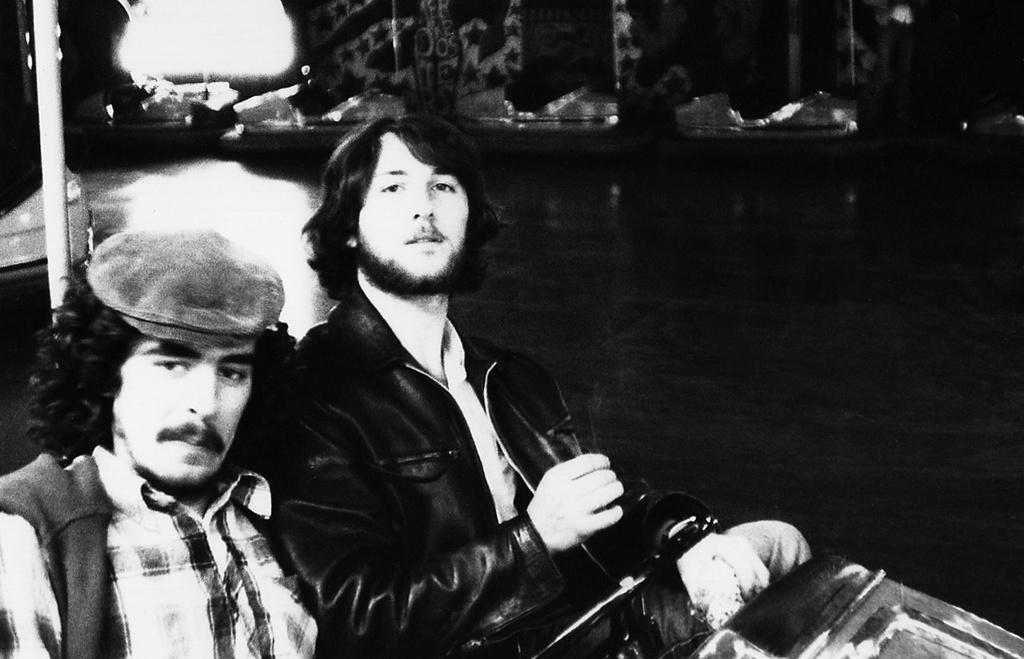How would you summarize this image in a sentence or two? This is a black and white image. On the left side, I can see two men are giving pose for the picture. The man who is on the left side is wearing a shirt and cap on the head. The man who is on the right side is wearing jacket. I can see the background in black color. At the back of these people there is a pole. 